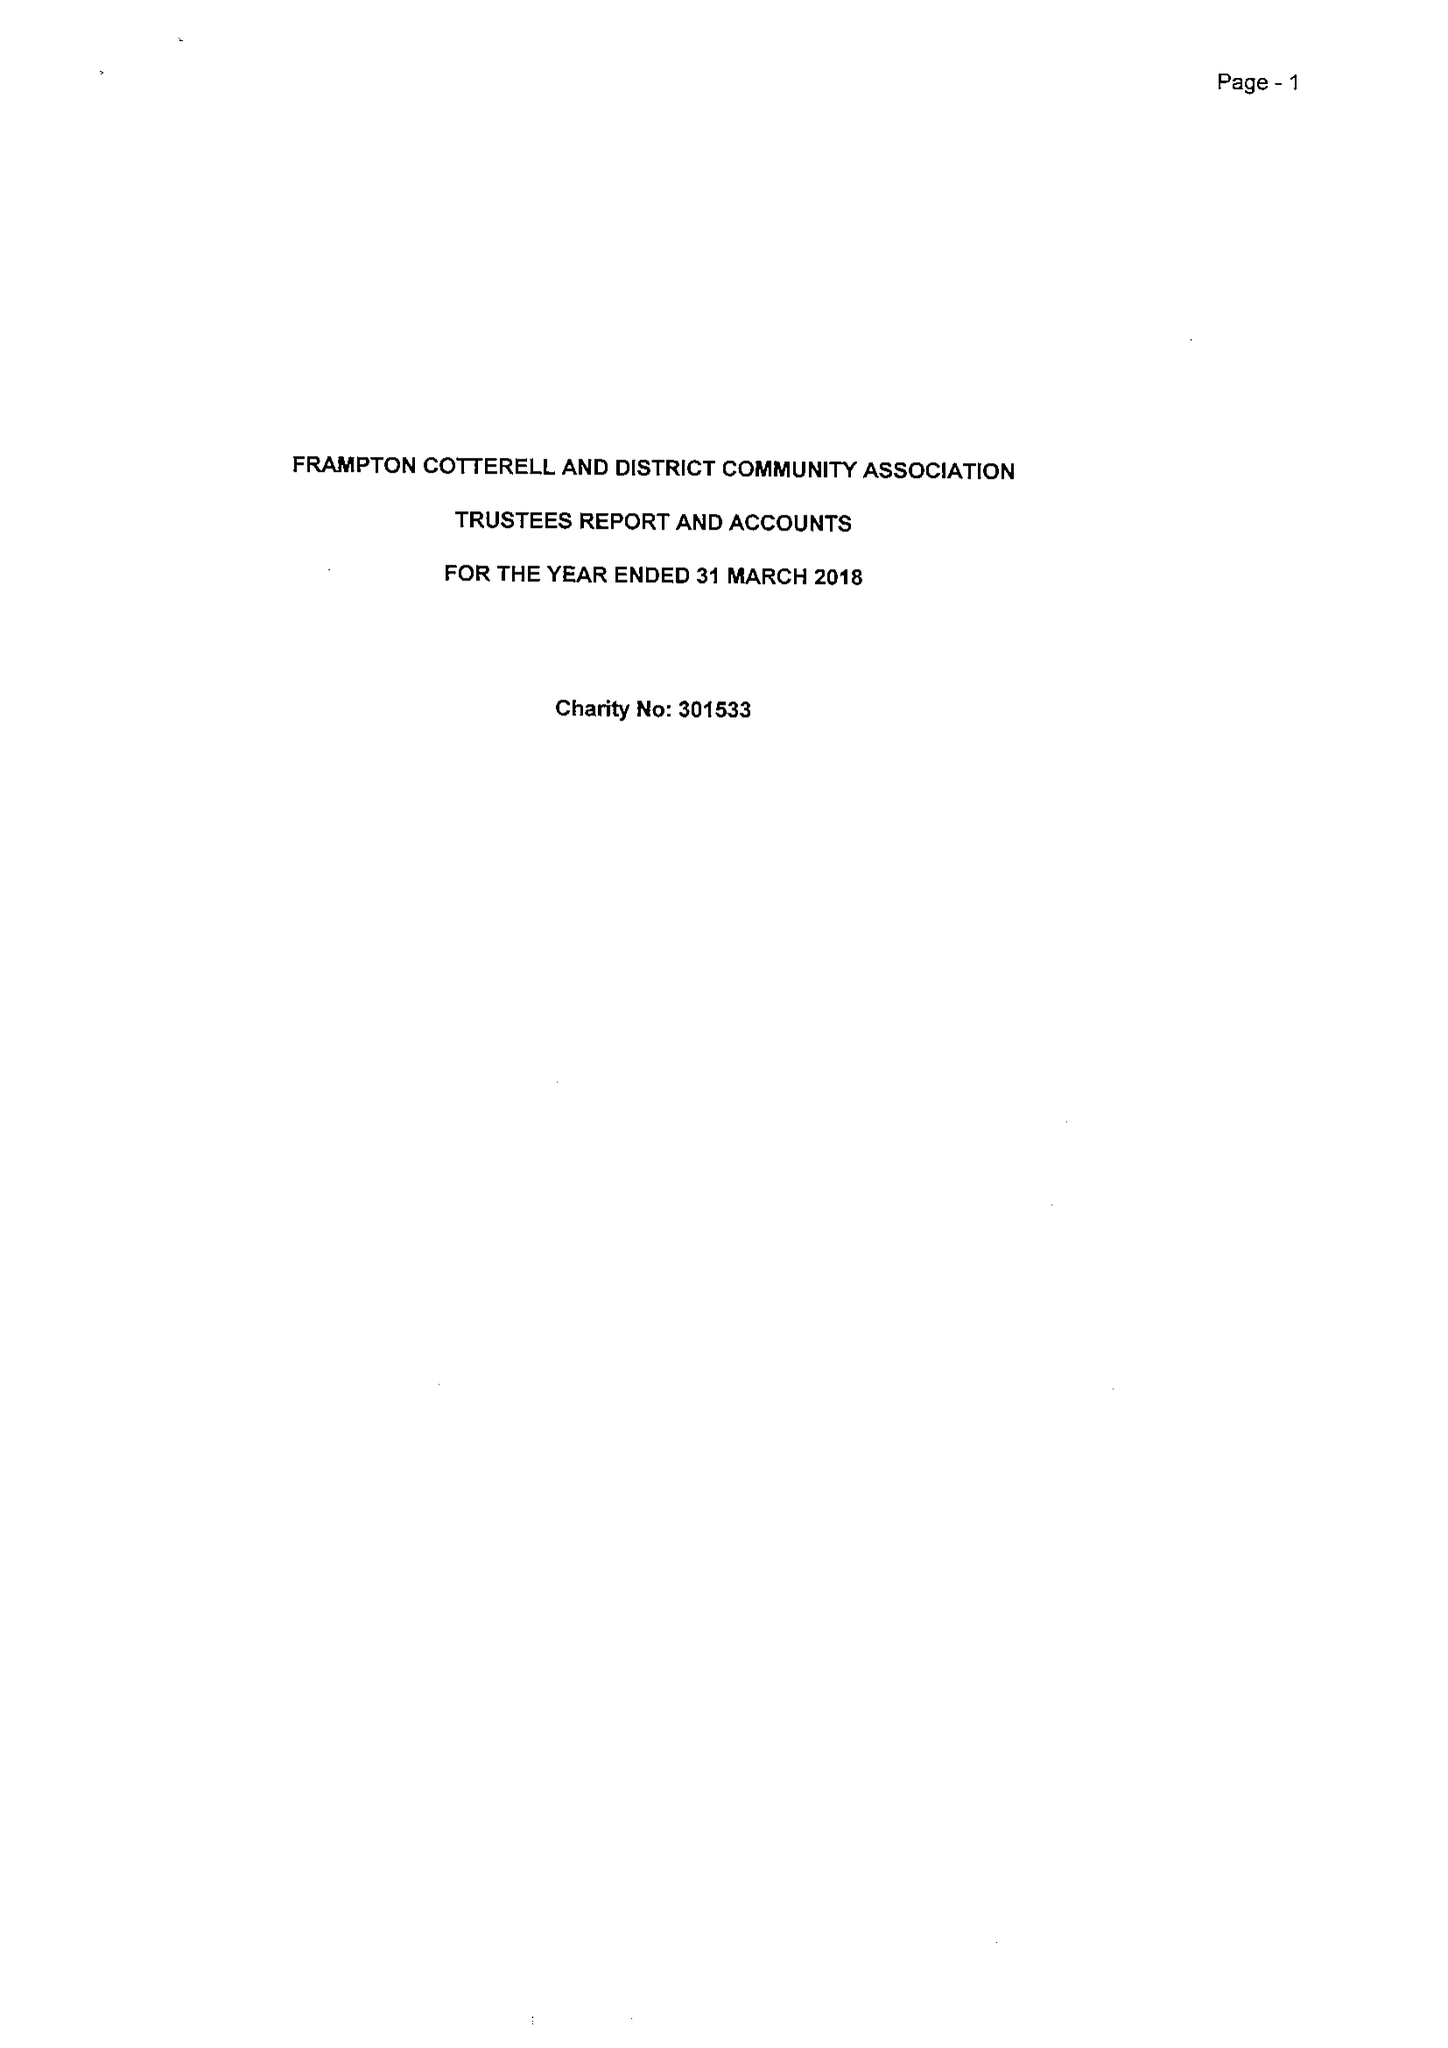What is the value for the charity_number?
Answer the question using a single word or phrase. 301533 